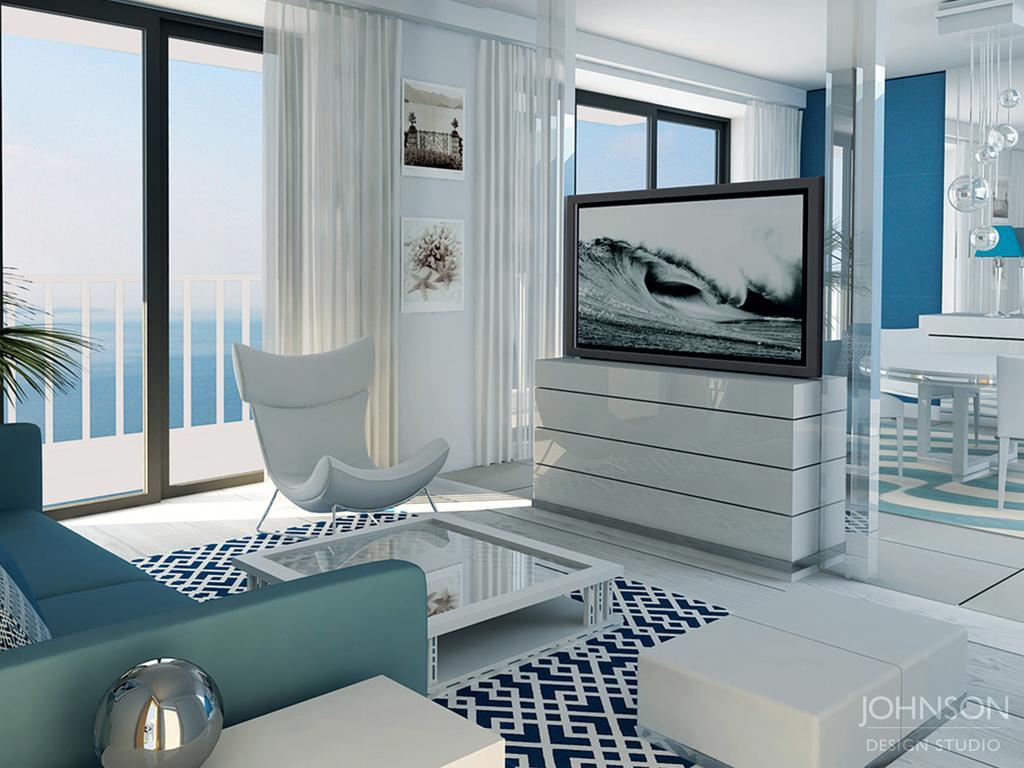Can you describe this image briefly? this is a image consist of a, in side of a room ,on the left side i can see a sofa set ,on the middle i can see a chair ,on the right side i can see a table monitor and there are photo frames attached to the wall ,on the middle i can see a fence and there is a sky visible and there is a leaf on the left side. 